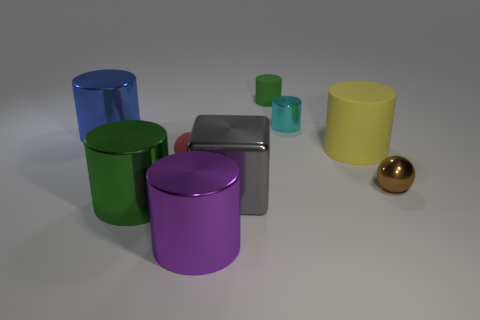Subtract all yellow cylinders. How many cylinders are left? 5 Subtract all tiny green rubber cylinders. How many cylinders are left? 5 Subtract all purple cylinders. Subtract all red cubes. How many cylinders are left? 5 Subtract all blocks. How many objects are left? 8 Add 3 yellow matte things. How many yellow matte things exist? 4 Subtract 0 cyan balls. How many objects are left? 9 Subtract all gray metal blocks. Subtract all matte objects. How many objects are left? 5 Add 9 large yellow rubber cylinders. How many large yellow rubber cylinders are left? 10 